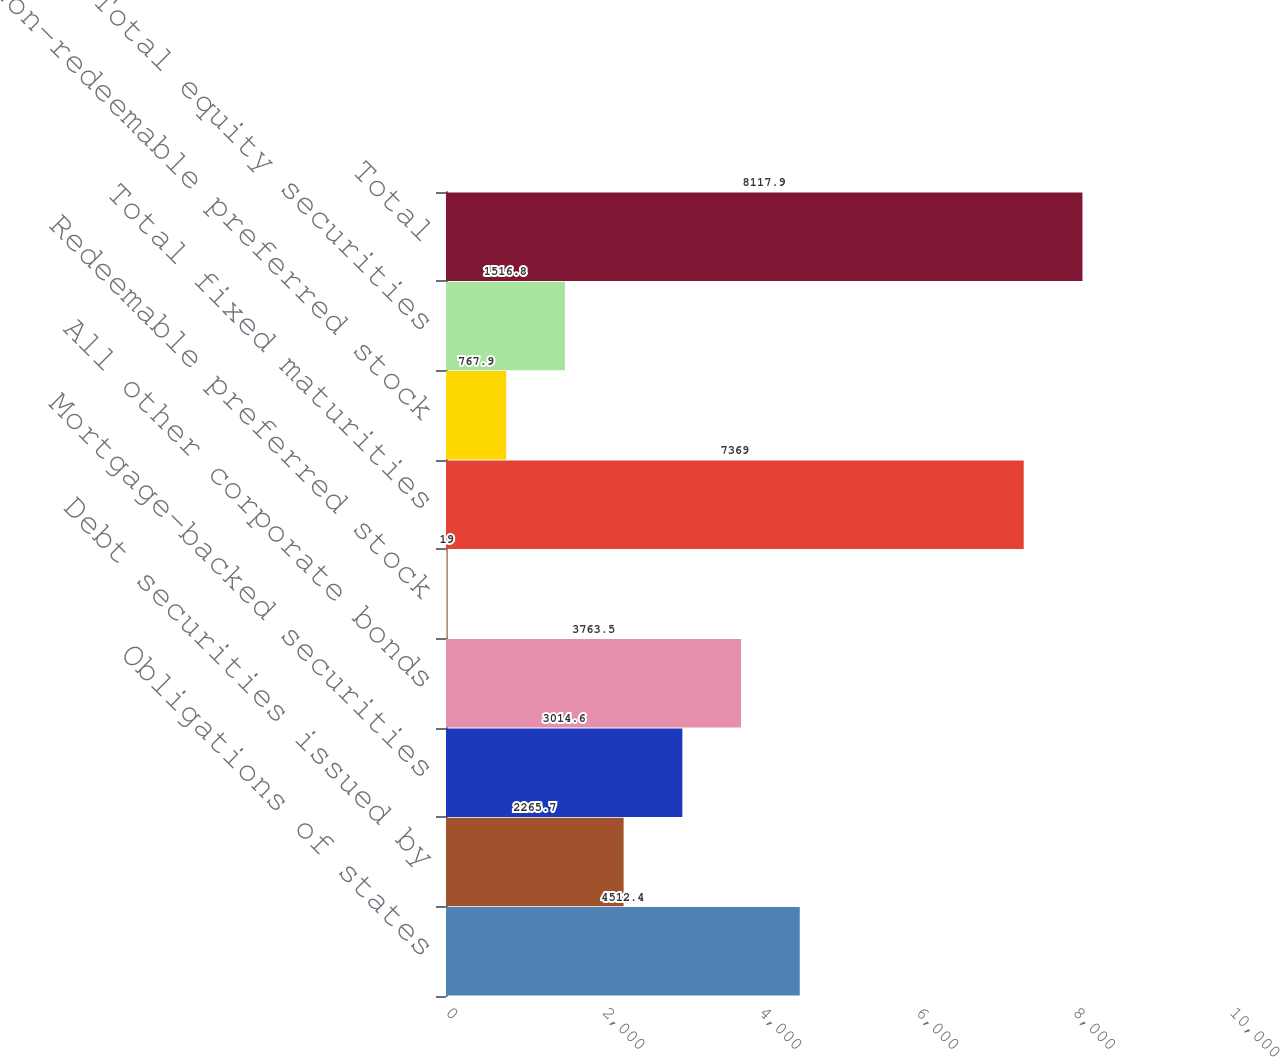Convert chart to OTSL. <chart><loc_0><loc_0><loc_500><loc_500><bar_chart><fcel>Obligations of states<fcel>Debt securities issued by<fcel>Mortgage-backed securities<fcel>All other corporate bonds<fcel>Redeemable preferred stock<fcel>Total fixed maturities<fcel>Non-redeemable preferred stock<fcel>Total equity securities<fcel>Total<nl><fcel>4512.4<fcel>2265.7<fcel>3014.6<fcel>3763.5<fcel>19<fcel>7369<fcel>767.9<fcel>1516.8<fcel>8117.9<nl></chart> 